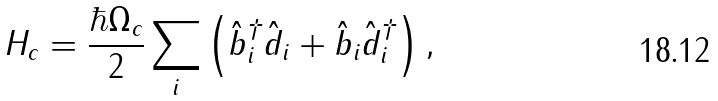Convert formula to latex. <formula><loc_0><loc_0><loc_500><loc_500>H _ { c } = \frac { \hbar { \Omega } _ { c } } { 2 } \sum _ { i } \left ( \hat { b } ^ { \dagger } _ { i } \hat { d } _ { i } + \hat { b } _ { i } \hat { d } ^ { \dagger } _ { i } \right ) ,</formula> 